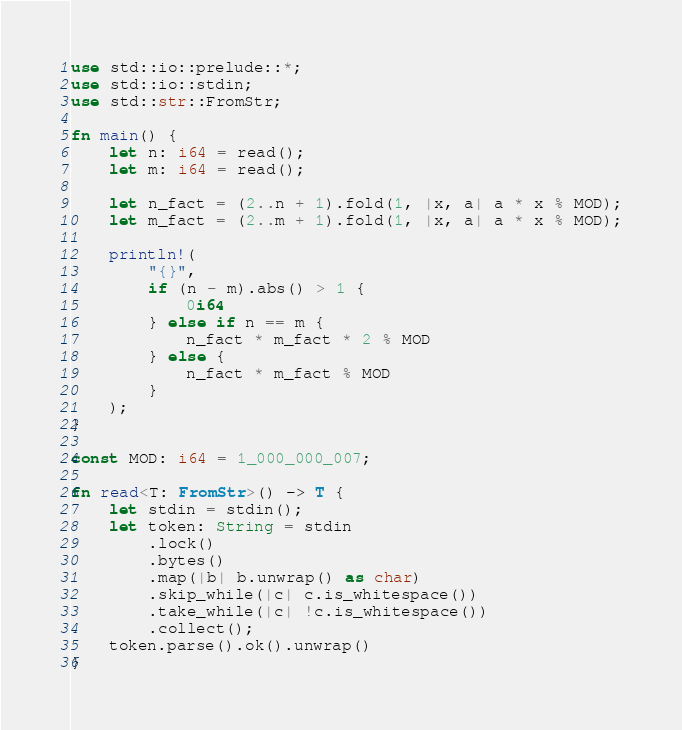Convert code to text. <code><loc_0><loc_0><loc_500><loc_500><_Rust_>use std::io::prelude::*;
use std::io::stdin;
use std::str::FromStr;

fn main() {
    let n: i64 = read();
    let m: i64 = read();

    let n_fact = (2..n + 1).fold(1, |x, a| a * x % MOD);
    let m_fact = (2..m + 1).fold(1, |x, a| a * x % MOD);

    println!(
        "{}",
        if (n - m).abs() > 1 {
            0i64
        } else if n == m {
            n_fact * m_fact * 2 % MOD
        } else {
            n_fact * m_fact % MOD
        }
    );
}

const MOD: i64 = 1_000_000_007;

fn read<T: FromStr>() -> T {
    let stdin = stdin();
    let token: String = stdin
        .lock()
        .bytes()
        .map(|b| b.unwrap() as char)
        .skip_while(|c| c.is_whitespace())
        .take_while(|c| !c.is_whitespace())
        .collect();
    token.parse().ok().unwrap()
}
</code> 